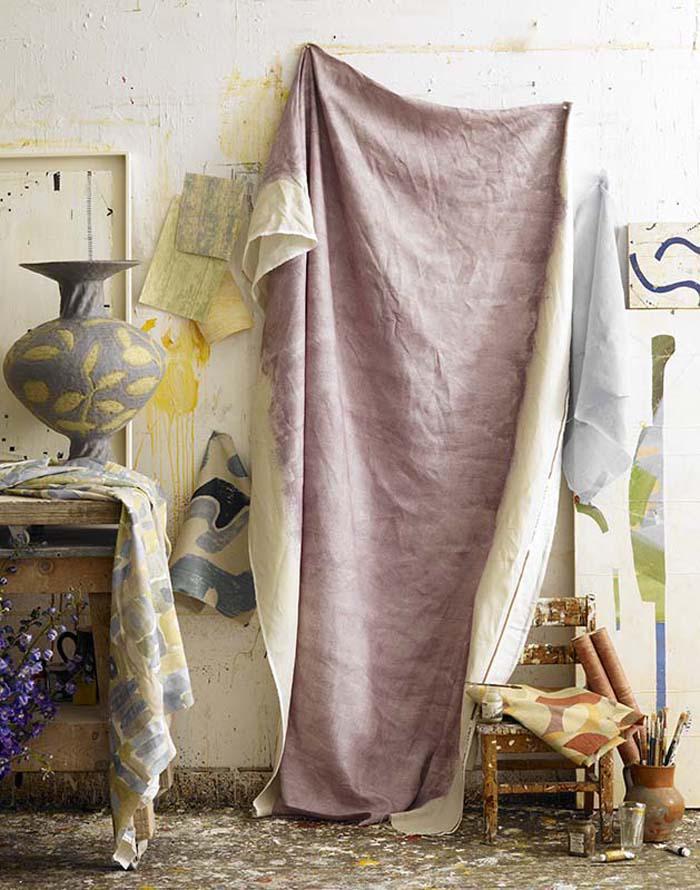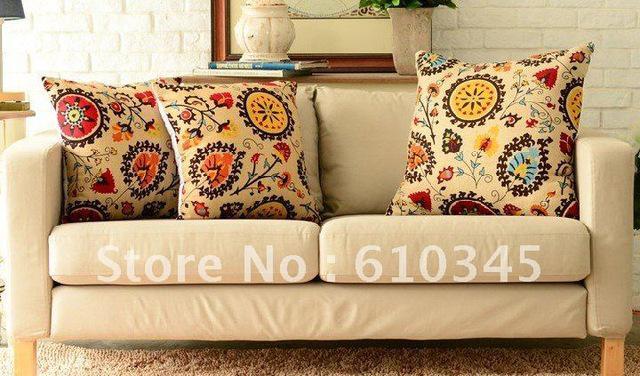The first image is the image on the left, the second image is the image on the right. Considering the images on both sides, is "All images include at least one pillow with text on it, and one image also includes two striped pillows." valid? Answer yes or no. No. The first image is the image on the left, the second image is the image on the right. Given the left and right images, does the statement "There are at least 7 pillows." hold true? Answer yes or no. No. 